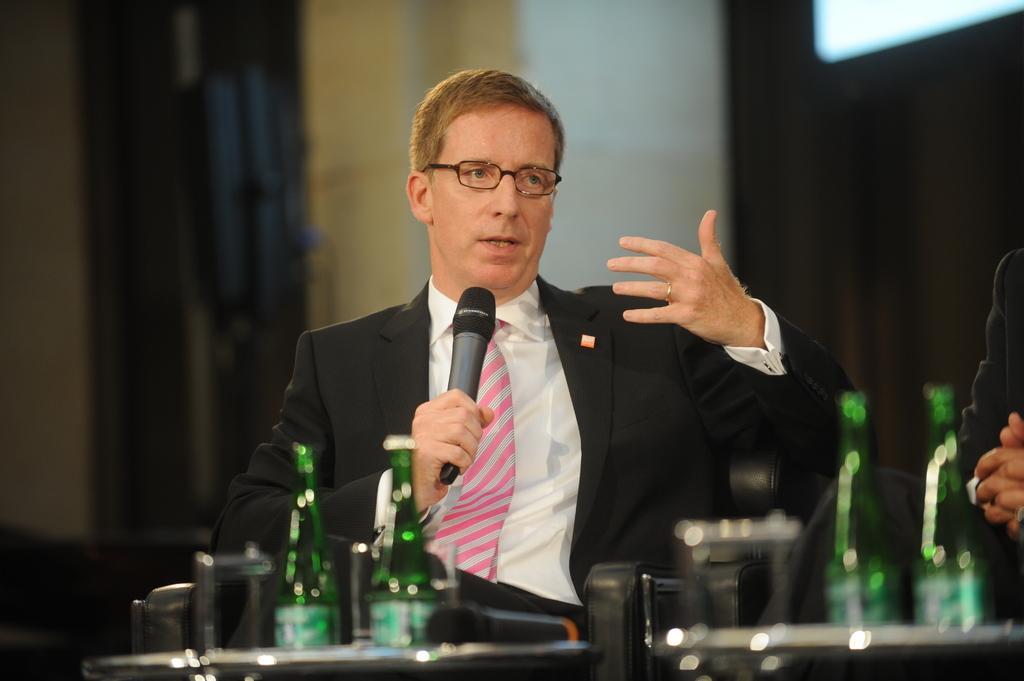Can you describe this image briefly? In the middle I can see a person is holding a mike in hand is sitting in the chair in front of a table on which I can see bottles and glasses. In the background I can see a wall and a curtain. This image is taken in a hall. 